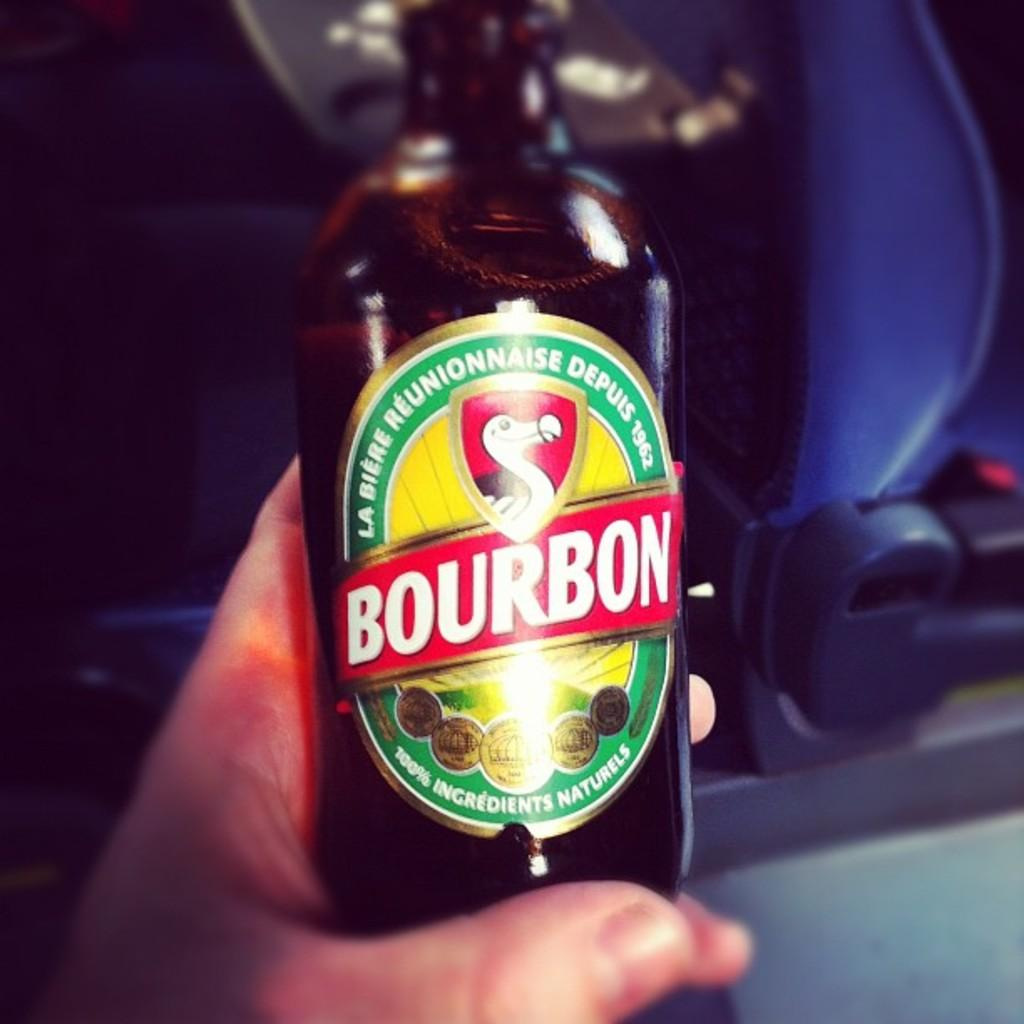<image>
Share a concise interpretation of the image provided. A hand with a glass bottle labeled BOURBON in white letters on a red, yellow, and green label. 